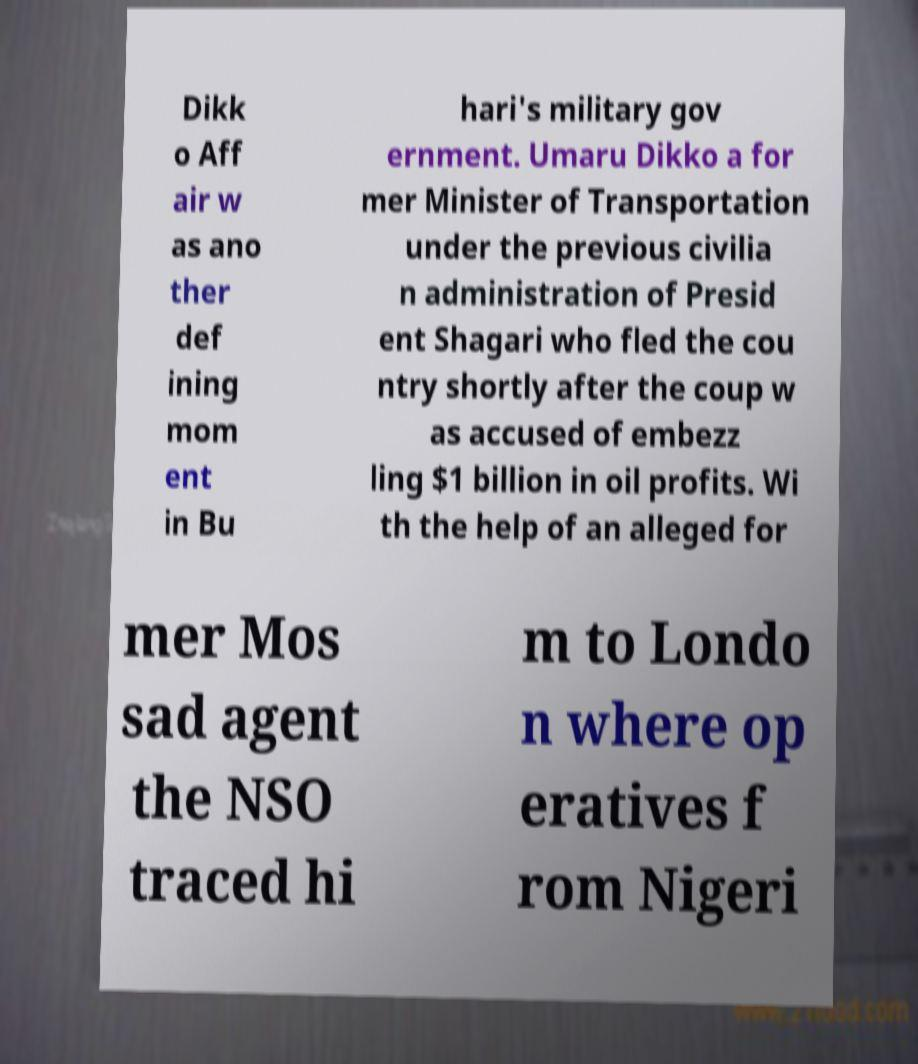What messages or text are displayed in this image? I need them in a readable, typed format. Dikk o Aff air w as ano ther def ining mom ent in Bu hari's military gov ernment. Umaru Dikko a for mer Minister of Transportation under the previous civilia n administration of Presid ent Shagari who fled the cou ntry shortly after the coup w as accused of embezz ling $1 billion in oil profits. Wi th the help of an alleged for mer Mos sad agent the NSO traced hi m to Londo n where op eratives f rom Nigeri 